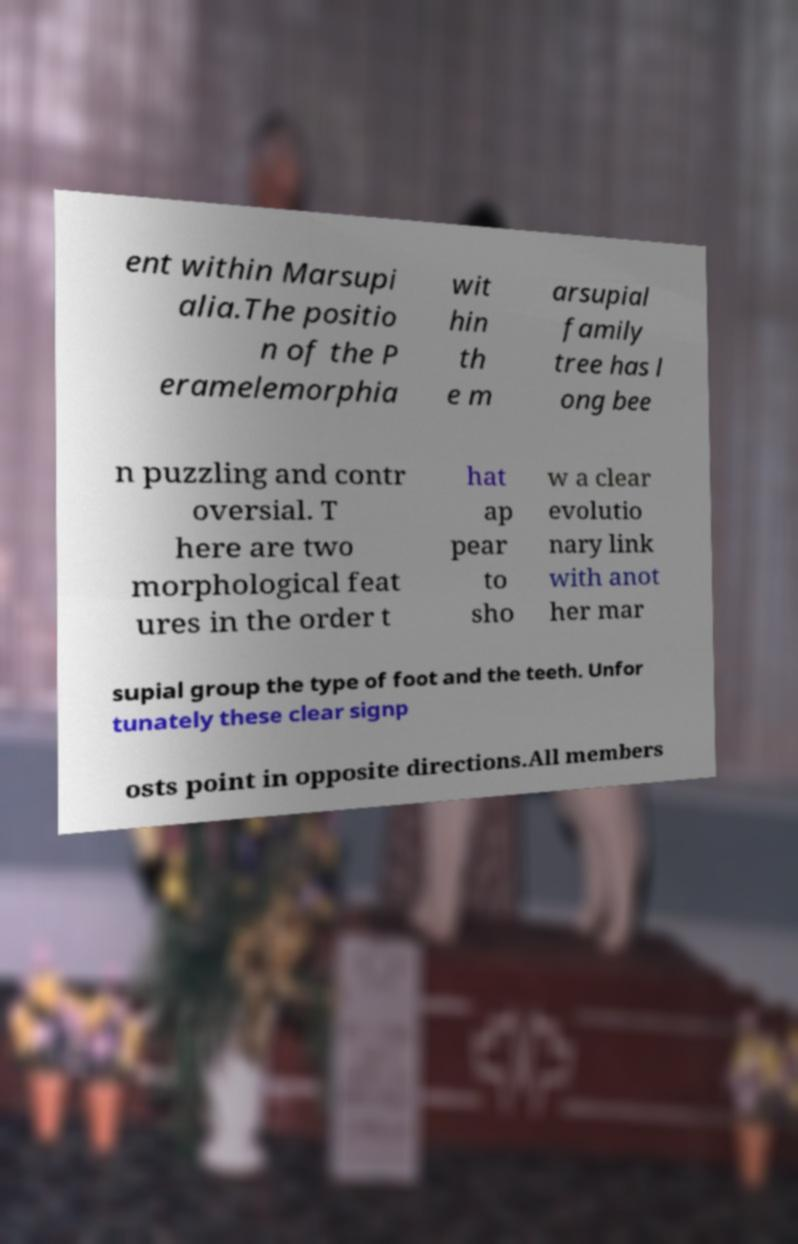Please identify and transcribe the text found in this image. ent within Marsupi alia.The positio n of the P eramelemorphia wit hin th e m arsupial family tree has l ong bee n puzzling and contr oversial. T here are two morphological feat ures in the order t hat ap pear to sho w a clear evolutio nary link with anot her mar supial group the type of foot and the teeth. Unfor tunately these clear signp osts point in opposite directions.All members 